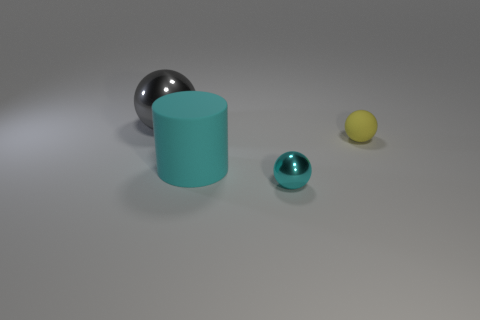How many other things are there of the same shape as the gray thing?
Make the answer very short. 2. Is the cyan cylinder the same size as the yellow ball?
Provide a succinct answer. No. Are there more cyan spheres in front of the large gray ball than cyan metal balls that are behind the big cyan cylinder?
Offer a very short reply. Yes. There is a rubber object that is left of the tiny shiny object; does it have the same color as the tiny shiny ball?
Your response must be concise. Yes. Is the number of objects on the right side of the big gray sphere greater than the number of small yellow matte things?
Your answer should be very brief. Yes. Is there any other thing that is the same color as the big cylinder?
Keep it short and to the point. Yes. There is a metallic thing on the right side of the metal sphere behind the tiny yellow object; what shape is it?
Make the answer very short. Sphere. Are there more small spheres than small yellow matte objects?
Make the answer very short. Yes. What number of things are both behind the cylinder and on the left side of the cyan metal sphere?
Keep it short and to the point. 1. There is a ball in front of the cyan rubber cylinder; how many cyan shiny things are on the left side of it?
Your answer should be very brief. 0. 